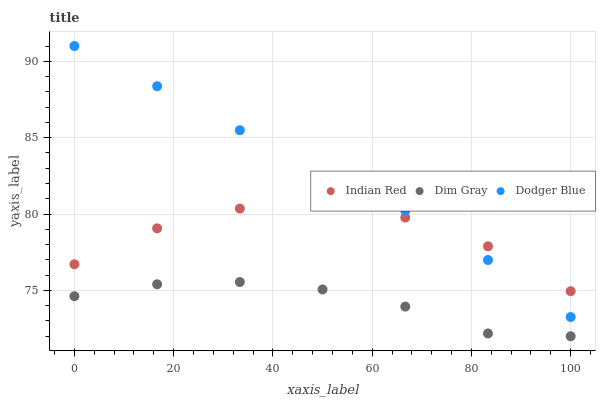Does Dim Gray have the minimum area under the curve?
Answer yes or no. Yes. Does Dodger Blue have the maximum area under the curve?
Answer yes or no. Yes. Does Indian Red have the minimum area under the curve?
Answer yes or no. No. Does Indian Red have the maximum area under the curve?
Answer yes or no. No. Is Dodger Blue the smoothest?
Answer yes or no. Yes. Is Indian Red the roughest?
Answer yes or no. Yes. Is Indian Red the smoothest?
Answer yes or no. No. Is Dodger Blue the roughest?
Answer yes or no. No. Does Dim Gray have the lowest value?
Answer yes or no. Yes. Does Dodger Blue have the lowest value?
Answer yes or no. No. Does Dodger Blue have the highest value?
Answer yes or no. Yes. Does Indian Red have the highest value?
Answer yes or no. No. Is Dim Gray less than Indian Red?
Answer yes or no. Yes. Is Indian Red greater than Dim Gray?
Answer yes or no. Yes. Does Dodger Blue intersect Indian Red?
Answer yes or no. Yes. Is Dodger Blue less than Indian Red?
Answer yes or no. No. Is Dodger Blue greater than Indian Red?
Answer yes or no. No. Does Dim Gray intersect Indian Red?
Answer yes or no. No. 